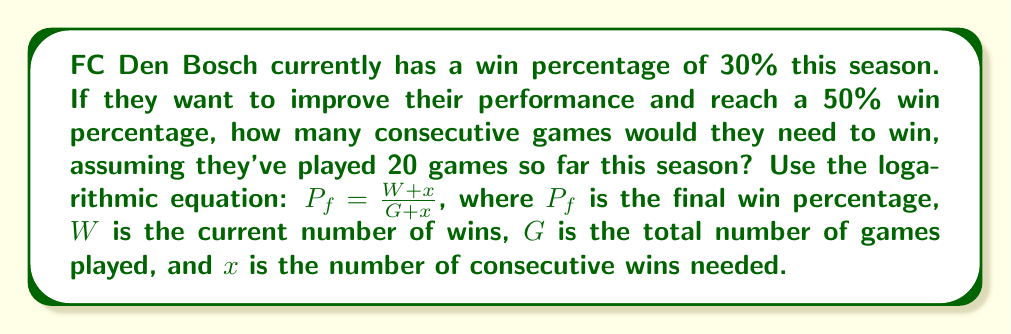Can you solve this math problem? Let's approach this step-by-step:

1) First, we need to determine the current number of wins:
   30% of 20 games = 0.3 × 20 = 6 wins

2) Now we can set up our equation:
   $$ 0.50 = \frac{6 + x}{20 + x} $$

3) Multiply both sides by $(20 + x)$:
   $$ 0.50(20 + x) = 6 + x $$

4) Expand the left side:
   $$ 10 + 0.50x = 6 + x $$

5) Subtract 6 from both sides:
   $$ 4 + 0.50x = x $$

6) Subtract 0.50x from both sides:
   $$ 4 = 0.50x $$

7) Multiply both sides by 2:
   $$ 8 = x $$

Therefore, FC Den Bosch would need to win 8 consecutive games to reach a 50% win percentage.

To verify:
$$ \frac{6 + 8}{20 + 8} = \frac{14}{28} = 0.50 $$

This checks out, confirming our calculation.
Answer: 8 consecutive wins 